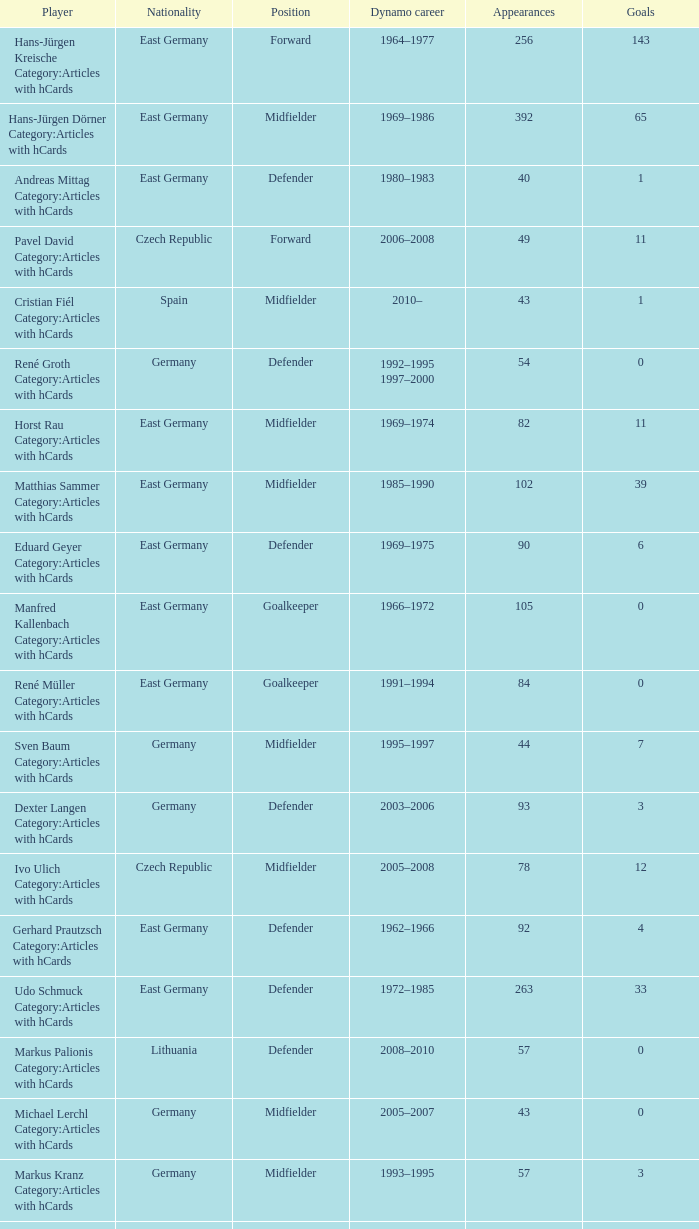What was the position of the player with 57 goals? Forward. 